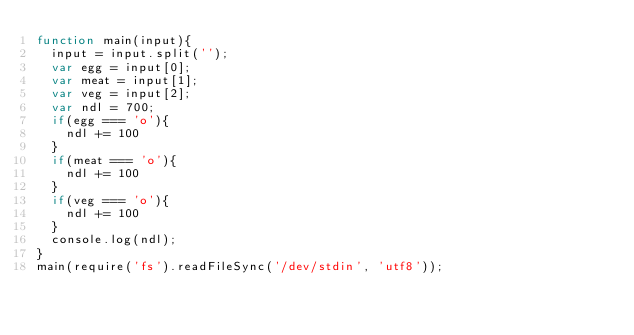Convert code to text. <code><loc_0><loc_0><loc_500><loc_500><_JavaScript_>function main(input){
  input = input.split('');
  var egg = input[0];
  var meat = input[1];
  var veg = input[2];
  var ndl = 700;
  if(egg === 'o'){
    ndl += 100
  }
  if(meat === 'o'){
    ndl += 100
  }
  if(veg === 'o'){
    ndl += 100
  }
  console.log(ndl);
}
main(require('fs').readFileSync('/dev/stdin', 'utf8'));</code> 